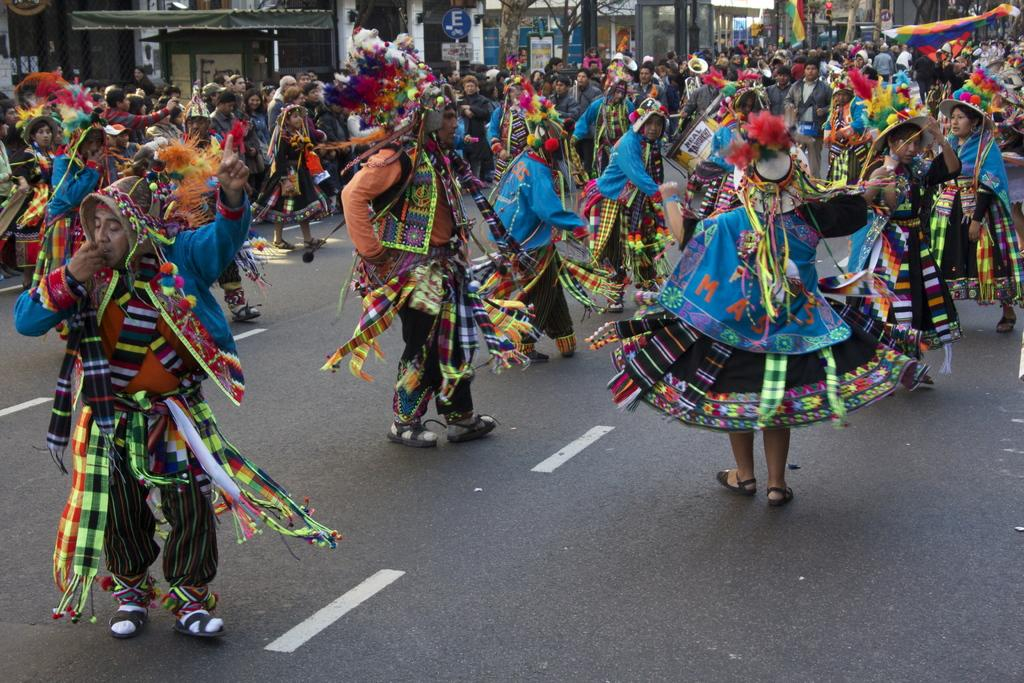What are the tribes doing in the image? The tribes are dancing on the road in the image. Are there any spectators in the image? Yes, people are watching the tribes at the back side. What type of natural elements can be seen in the image? There are trees in the image. What type of man-made structures are present in the image? There are buildings in the image. What type of spy equipment can be seen in the image? There is no spy equipment present in the image. What wish is being granted to the tribes in the image? There is no indication of a wish being granted in the image. 